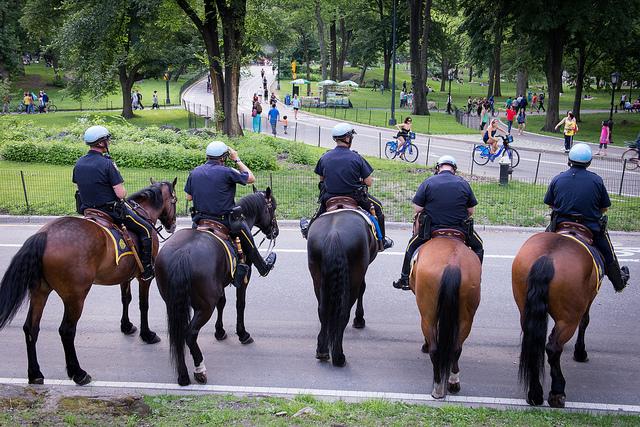Are all the horsemen cops?
Be succinct. Yes. Why do they all wear head protection?
Short answer required. Safety. What color are the horses' tails?
Give a very brief answer. Black. 